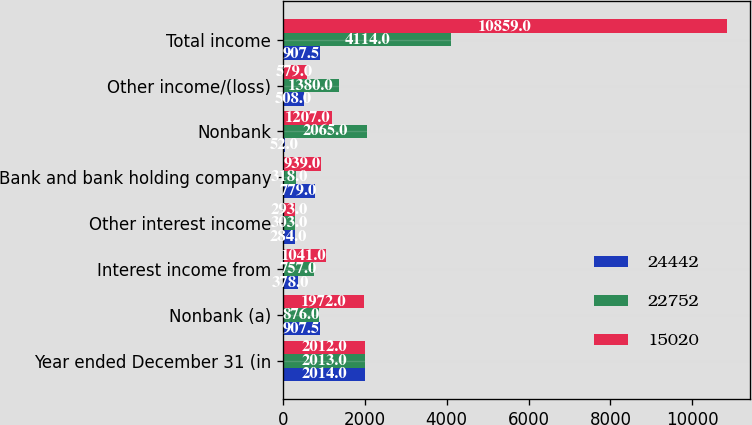<chart> <loc_0><loc_0><loc_500><loc_500><stacked_bar_chart><ecel><fcel>Year ended December 31 (in<fcel>Nonbank (a)<fcel>Interest income from<fcel>Other interest income<fcel>Bank and bank holding company<fcel>Nonbank<fcel>Other income/(loss)<fcel>Total income<nl><fcel>24442<fcel>2014<fcel>907.5<fcel>378<fcel>284<fcel>779<fcel>52<fcel>508<fcel>907.5<nl><fcel>22752<fcel>2013<fcel>876<fcel>757<fcel>303<fcel>318<fcel>2065<fcel>1380<fcel>4114<nl><fcel>15020<fcel>2012<fcel>1972<fcel>1041<fcel>293<fcel>939<fcel>1207<fcel>579<fcel>10859<nl></chart> 